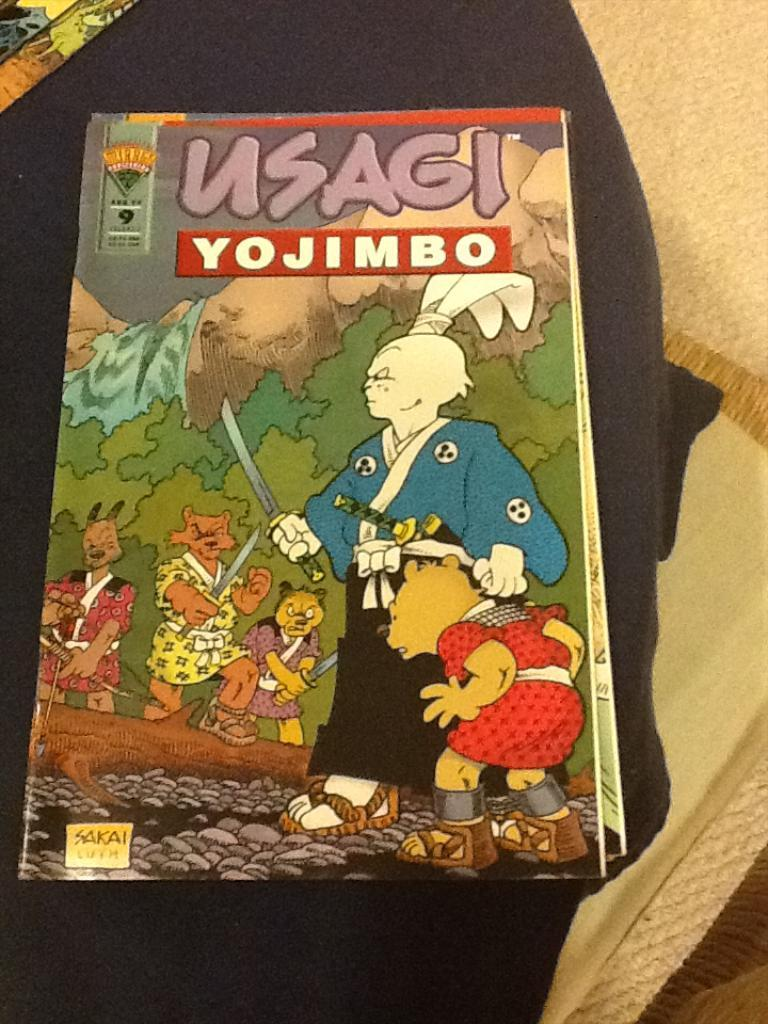<image>
Relay a brief, clear account of the picture shown. A paperback copy of the classic manga usagi yojimbo 